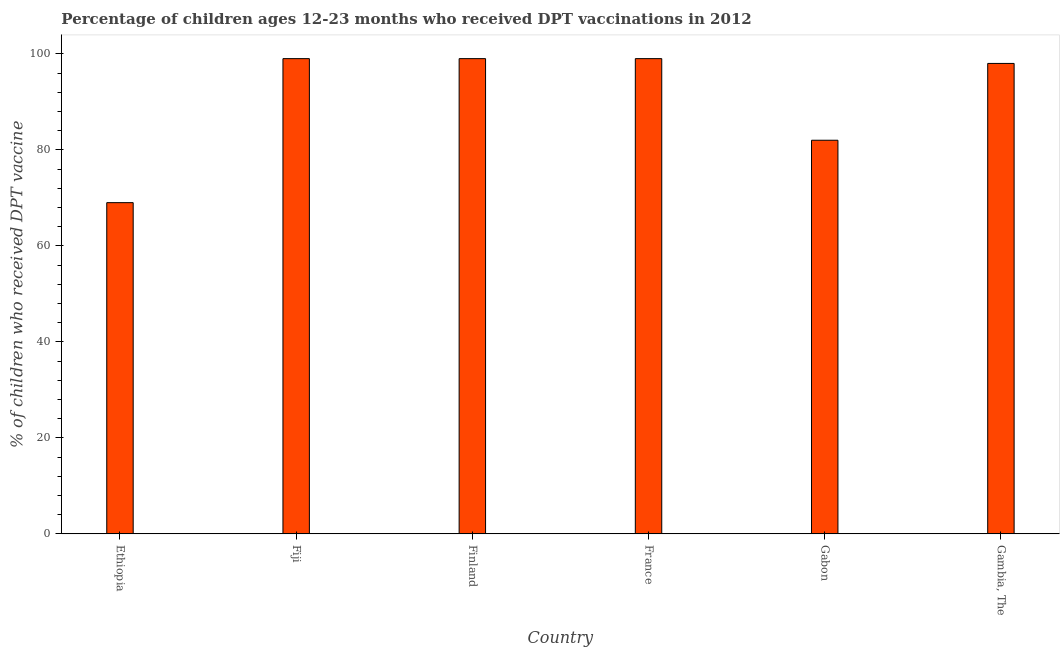Does the graph contain any zero values?
Your answer should be very brief. No. What is the title of the graph?
Provide a succinct answer. Percentage of children ages 12-23 months who received DPT vaccinations in 2012. What is the label or title of the X-axis?
Your answer should be compact. Country. What is the label or title of the Y-axis?
Provide a succinct answer. % of children who received DPT vaccine. Across all countries, what is the maximum percentage of children who received dpt vaccine?
Your response must be concise. 99. In which country was the percentage of children who received dpt vaccine maximum?
Provide a short and direct response. Fiji. In which country was the percentage of children who received dpt vaccine minimum?
Your answer should be compact. Ethiopia. What is the sum of the percentage of children who received dpt vaccine?
Provide a short and direct response. 546. What is the difference between the percentage of children who received dpt vaccine in France and Gambia, The?
Provide a short and direct response. 1. What is the average percentage of children who received dpt vaccine per country?
Ensure brevity in your answer.  91. What is the median percentage of children who received dpt vaccine?
Offer a very short reply. 98.5. In how many countries, is the percentage of children who received dpt vaccine greater than 80 %?
Your answer should be compact. 5. What is the ratio of the percentage of children who received dpt vaccine in Fiji to that in Gabon?
Offer a terse response. 1.21. Is the percentage of children who received dpt vaccine in Finland less than that in Gambia, The?
Make the answer very short. No. What is the difference between the highest and the second highest percentage of children who received dpt vaccine?
Offer a terse response. 0. Is the sum of the percentage of children who received dpt vaccine in Fiji and Gabon greater than the maximum percentage of children who received dpt vaccine across all countries?
Offer a very short reply. Yes. What is the difference between the highest and the lowest percentage of children who received dpt vaccine?
Your response must be concise. 30. What is the difference between two consecutive major ticks on the Y-axis?
Offer a very short reply. 20. What is the % of children who received DPT vaccine of Ethiopia?
Offer a terse response. 69. What is the % of children who received DPT vaccine of France?
Your answer should be compact. 99. What is the % of children who received DPT vaccine in Gabon?
Your answer should be compact. 82. What is the % of children who received DPT vaccine in Gambia, The?
Ensure brevity in your answer.  98. What is the difference between the % of children who received DPT vaccine in Ethiopia and Gabon?
Offer a terse response. -13. What is the difference between the % of children who received DPT vaccine in Fiji and France?
Your answer should be compact. 0. What is the difference between the % of children who received DPT vaccine in Fiji and Gabon?
Provide a short and direct response. 17. What is the difference between the % of children who received DPT vaccine in Fiji and Gambia, The?
Ensure brevity in your answer.  1. What is the difference between the % of children who received DPT vaccine in Finland and France?
Keep it short and to the point. 0. What is the difference between the % of children who received DPT vaccine in Finland and Gabon?
Your response must be concise. 17. What is the difference between the % of children who received DPT vaccine in Finland and Gambia, The?
Your answer should be very brief. 1. What is the difference between the % of children who received DPT vaccine in Gabon and Gambia, The?
Your answer should be very brief. -16. What is the ratio of the % of children who received DPT vaccine in Ethiopia to that in Fiji?
Offer a very short reply. 0.7. What is the ratio of the % of children who received DPT vaccine in Ethiopia to that in Finland?
Offer a terse response. 0.7. What is the ratio of the % of children who received DPT vaccine in Ethiopia to that in France?
Provide a short and direct response. 0.7. What is the ratio of the % of children who received DPT vaccine in Ethiopia to that in Gabon?
Your answer should be compact. 0.84. What is the ratio of the % of children who received DPT vaccine in Ethiopia to that in Gambia, The?
Offer a terse response. 0.7. What is the ratio of the % of children who received DPT vaccine in Fiji to that in Gabon?
Your answer should be compact. 1.21. What is the ratio of the % of children who received DPT vaccine in Fiji to that in Gambia, The?
Keep it short and to the point. 1.01. What is the ratio of the % of children who received DPT vaccine in Finland to that in Gabon?
Provide a succinct answer. 1.21. What is the ratio of the % of children who received DPT vaccine in France to that in Gabon?
Ensure brevity in your answer.  1.21. What is the ratio of the % of children who received DPT vaccine in Gabon to that in Gambia, The?
Offer a very short reply. 0.84. 